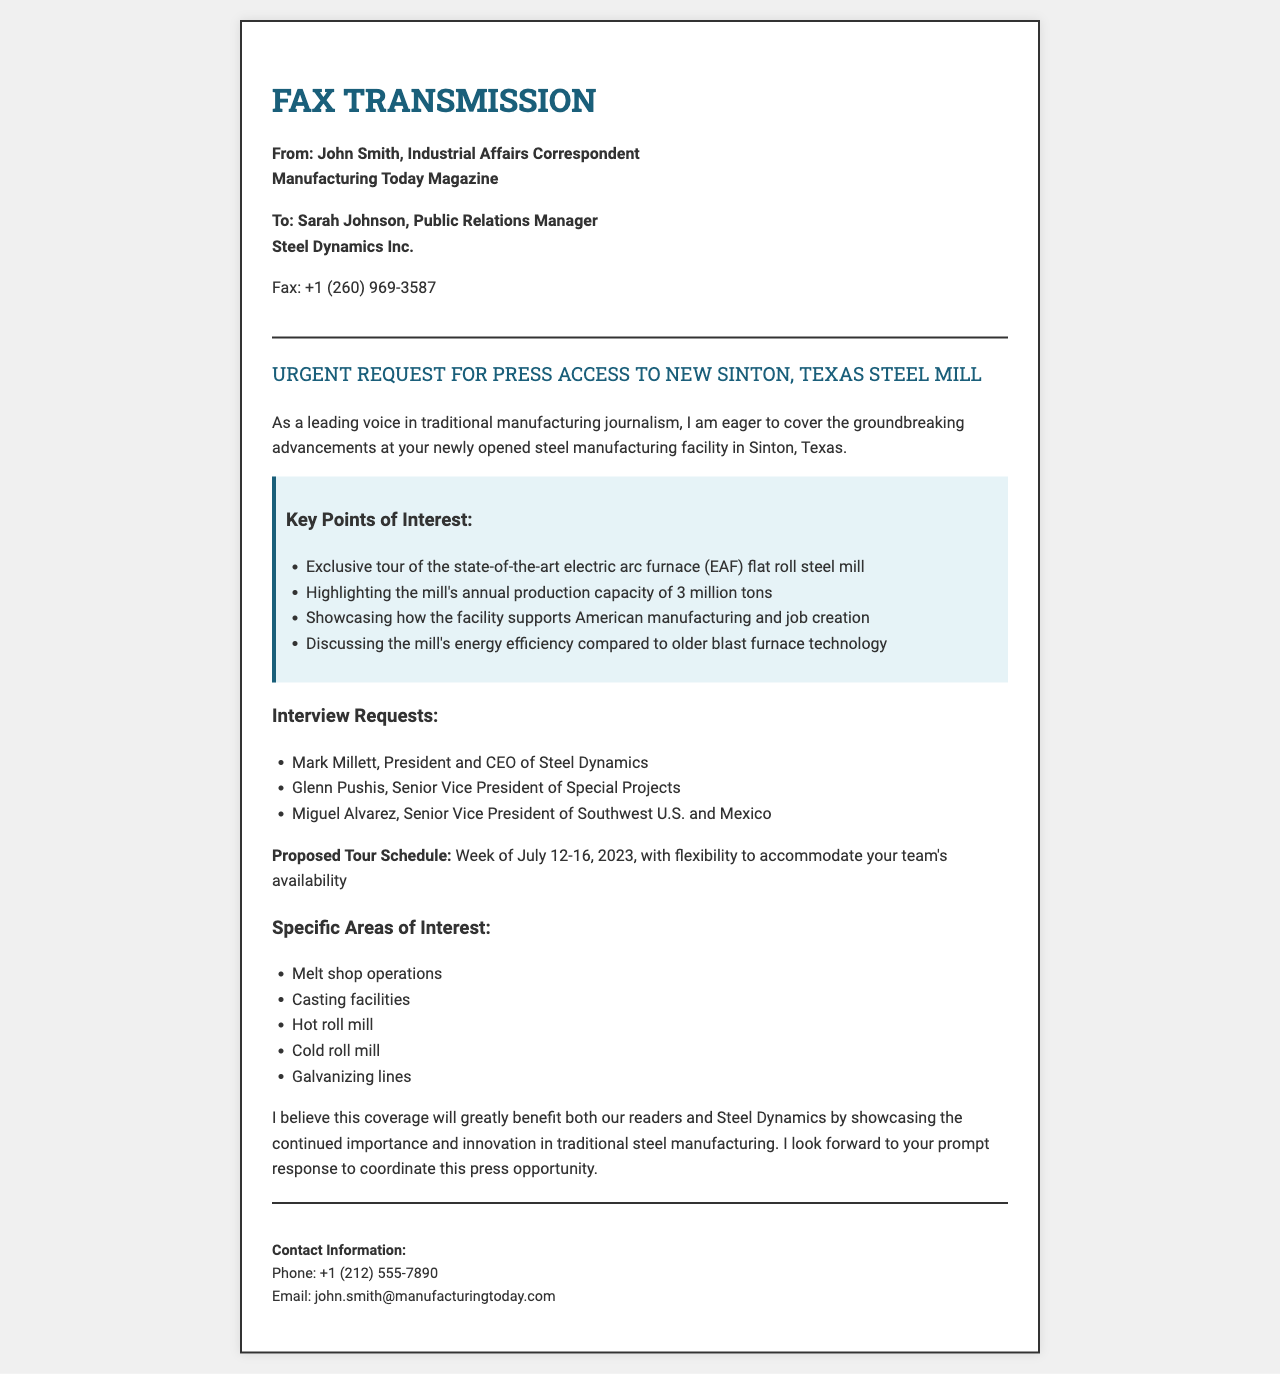What is the name of the sender? The sender is John Smith, as stated in the document.
Answer: John Smith Who is the recipient of the fax? The recipient of the fax is Sarah Johnson, as outlined in the document.
Answer: Sarah Johnson What is the subject of the fax? The subject is mentioned clearly in the document, focusing on the press access request.
Answer: Urgent Request for Press Access to New Sinton, Texas Steel Mill What is the proposed tour schedule date? The proposed tour schedule is specified for the week of July 12-16, 2023.
Answer: Week of July 12-16, 2023 How many tons can the new steel mill produce annually? The document states the mill's annual production capacity explicitly.
Answer: 3 million tons Which technology is the new facility contrasting with? The document makes a comparison between the new facility's technology and an older method.
Answer: Blast furnace technology Who is the President and CEO of Steel Dynamics? The document provides the name of the President and CEO for interview requests.
Answer: Mark Millett What is one area of interest mentioned for the tour? The document lists several areas of interest for the tour, asking for specific information on them.
Answer: Melt shop operations What title does Glenn Pushis hold? The document specifies the title of Glenn Pushis in relation to the company.
Answer: Senior Vice President of Special Projects 